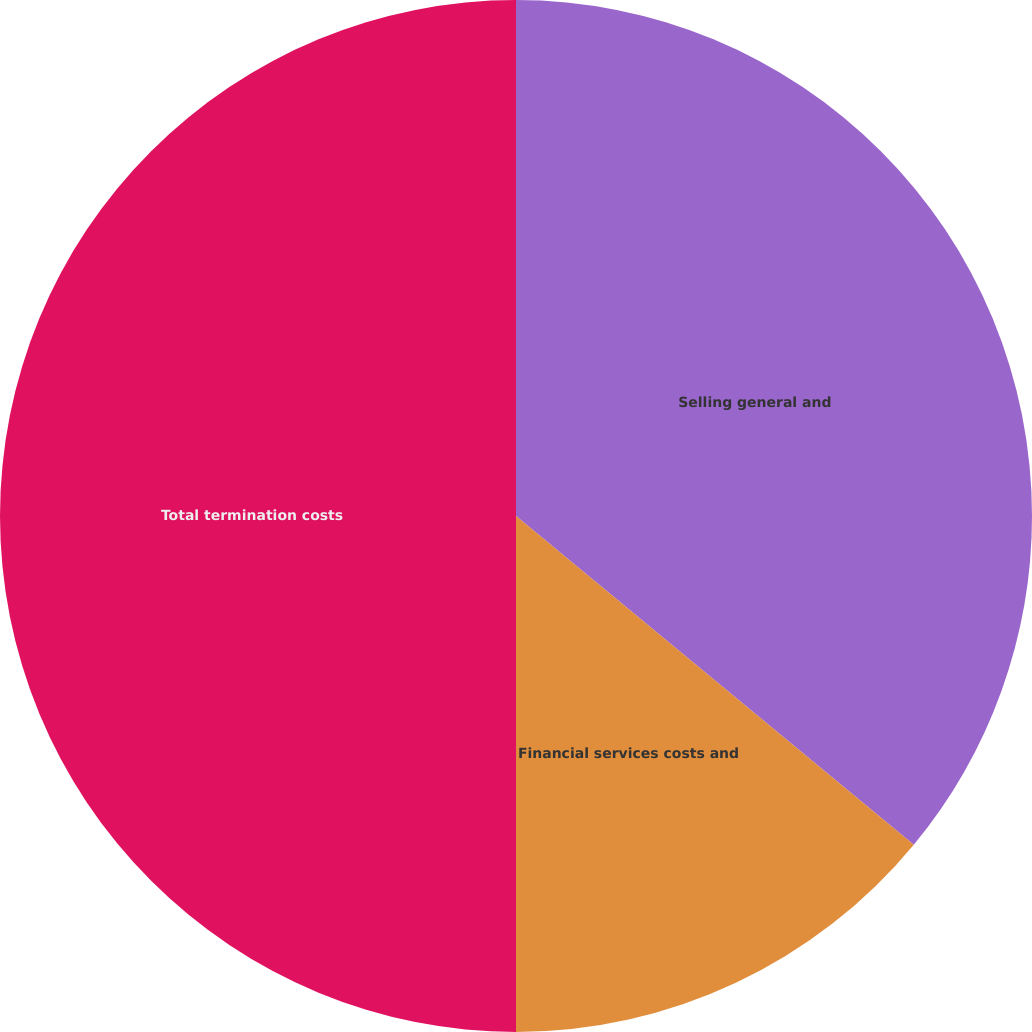Convert chart to OTSL. <chart><loc_0><loc_0><loc_500><loc_500><pie_chart><fcel>Selling general and<fcel>Financial services costs and<fcel>Total termination costs<nl><fcel>35.99%<fcel>14.01%<fcel>50.0%<nl></chart> 